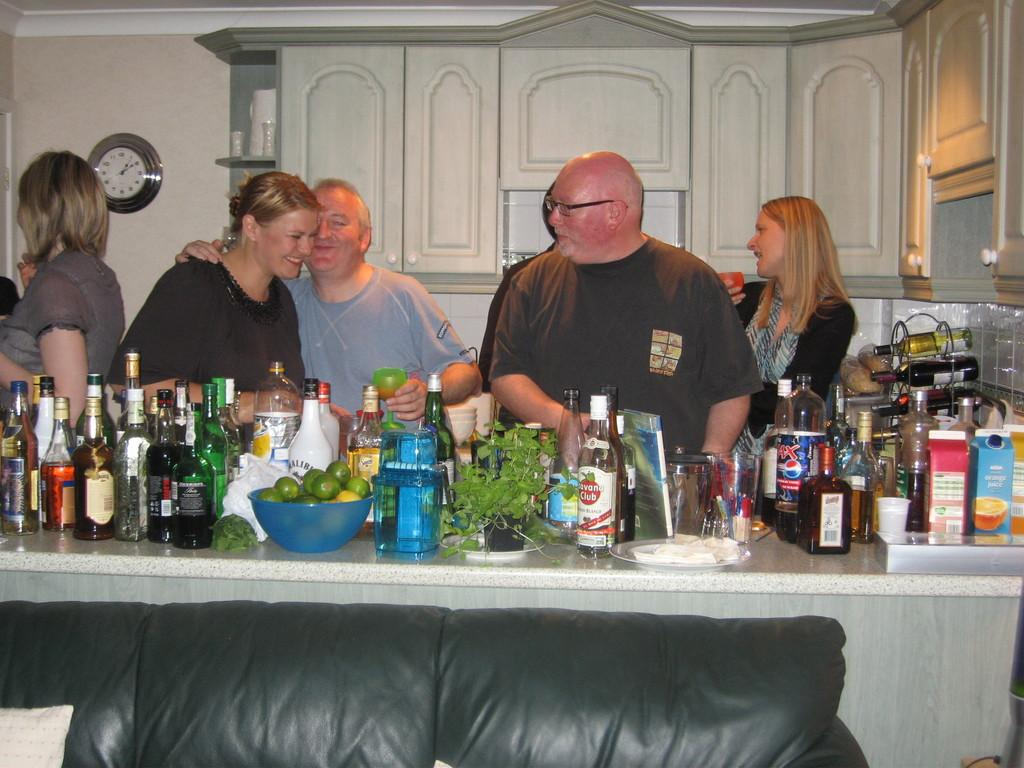<image>
Describe the image concisely. A party in a residence hase a large spread of drinks and snacks, including Pepsi Max. 